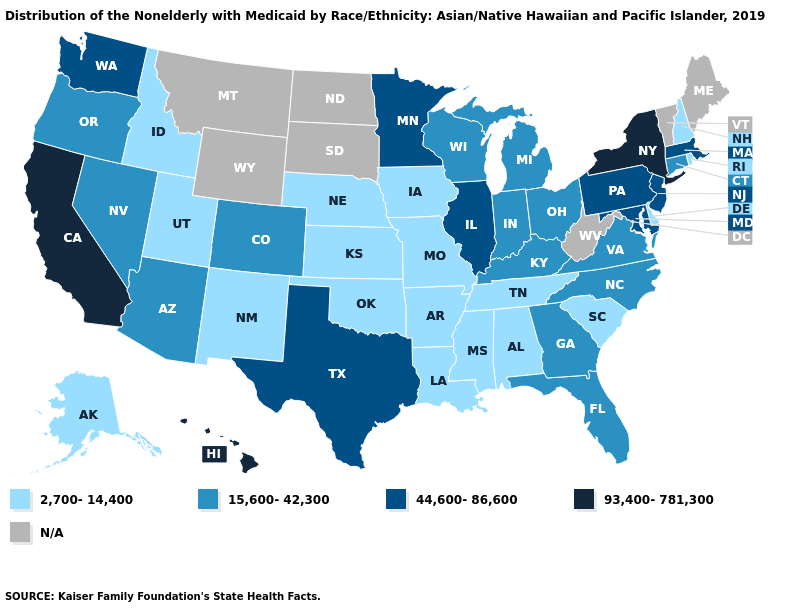Which states have the lowest value in the West?
Answer briefly. Alaska, Idaho, New Mexico, Utah. What is the value of Georgia?
Concise answer only. 15,600-42,300. Does Maryland have the lowest value in the South?
Concise answer only. No. What is the value of Utah?
Short answer required. 2,700-14,400. What is the value of Indiana?
Answer briefly. 15,600-42,300. What is the value of Montana?
Concise answer only. N/A. What is the value of Colorado?
Be succinct. 15,600-42,300. Name the states that have a value in the range 15,600-42,300?
Give a very brief answer. Arizona, Colorado, Connecticut, Florida, Georgia, Indiana, Kentucky, Michigan, Nevada, North Carolina, Ohio, Oregon, Virginia, Wisconsin. What is the value of North Carolina?
Concise answer only. 15,600-42,300. Among the states that border Michigan , which have the highest value?
Short answer required. Indiana, Ohio, Wisconsin. What is the value of California?
Keep it brief. 93,400-781,300. Among the states that border Utah , which have the highest value?
Quick response, please. Arizona, Colorado, Nevada. Is the legend a continuous bar?
Answer briefly. No. What is the highest value in the Northeast ?
Answer briefly. 93,400-781,300. 